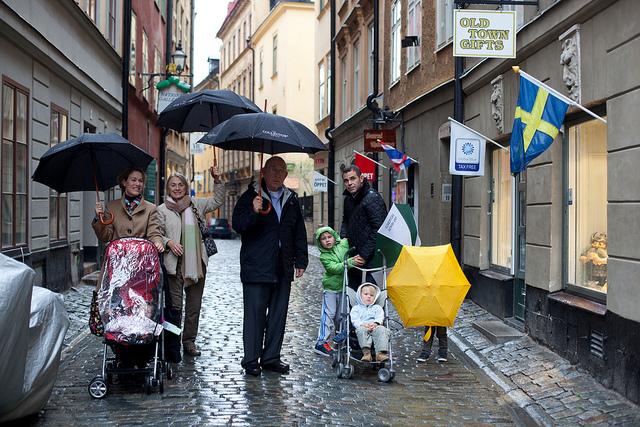How many strollers are there?
Keep it brief. 2. Which color of umbrella are many?
Concise answer only. Black. How many flags are there?
Quick response, please. 5. 